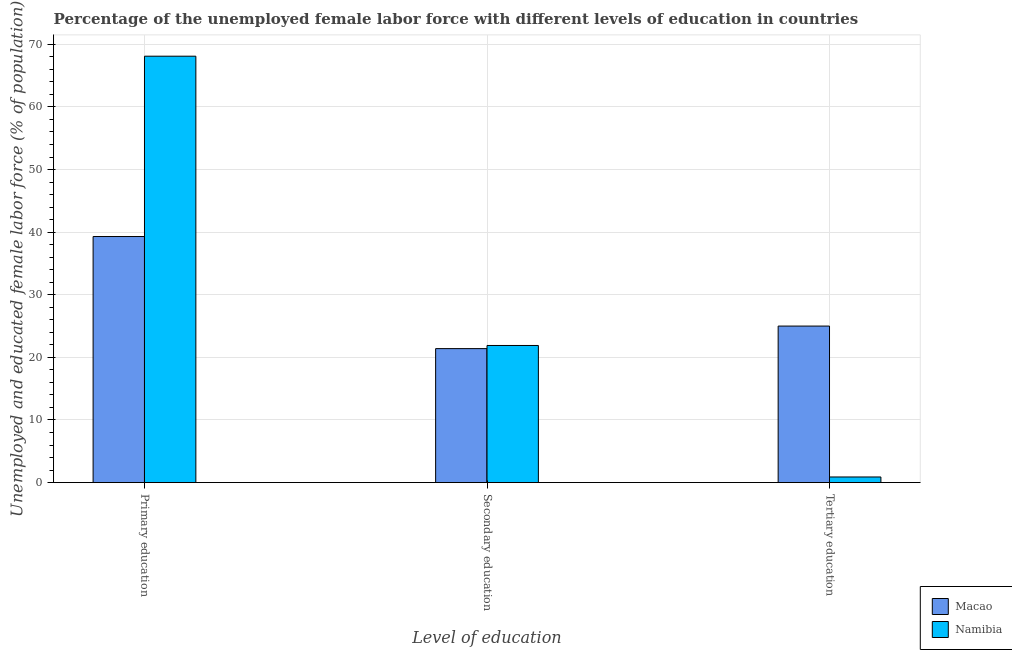How many bars are there on the 1st tick from the right?
Provide a succinct answer. 2. What is the label of the 3rd group of bars from the left?
Your response must be concise. Tertiary education. What is the percentage of female labor force who received tertiary education in Namibia?
Make the answer very short. 0.9. Across all countries, what is the maximum percentage of female labor force who received tertiary education?
Provide a short and direct response. 25. Across all countries, what is the minimum percentage of female labor force who received primary education?
Offer a very short reply. 39.3. In which country was the percentage of female labor force who received tertiary education maximum?
Your response must be concise. Macao. In which country was the percentage of female labor force who received tertiary education minimum?
Offer a very short reply. Namibia. What is the total percentage of female labor force who received tertiary education in the graph?
Offer a very short reply. 25.9. What is the difference between the percentage of female labor force who received secondary education in Macao and that in Namibia?
Ensure brevity in your answer.  -0.5. What is the difference between the percentage of female labor force who received primary education in Namibia and the percentage of female labor force who received tertiary education in Macao?
Give a very brief answer. 43.1. What is the average percentage of female labor force who received tertiary education per country?
Offer a very short reply. 12.95. What is the difference between the percentage of female labor force who received primary education and percentage of female labor force who received tertiary education in Namibia?
Your answer should be compact. 67.2. In how many countries, is the percentage of female labor force who received secondary education greater than 24 %?
Offer a very short reply. 0. What is the ratio of the percentage of female labor force who received primary education in Namibia to that in Macao?
Offer a terse response. 1.73. Is the difference between the percentage of female labor force who received tertiary education in Macao and Namibia greater than the difference between the percentage of female labor force who received primary education in Macao and Namibia?
Offer a terse response. Yes. What is the difference between the highest and the second highest percentage of female labor force who received secondary education?
Give a very brief answer. 0.5. What is the difference between the highest and the lowest percentage of female labor force who received tertiary education?
Your answer should be very brief. 24.1. What does the 2nd bar from the left in Secondary education represents?
Keep it short and to the point. Namibia. What does the 2nd bar from the right in Tertiary education represents?
Provide a succinct answer. Macao. Are all the bars in the graph horizontal?
Make the answer very short. No. How many countries are there in the graph?
Give a very brief answer. 2. Does the graph contain any zero values?
Provide a short and direct response. No. Where does the legend appear in the graph?
Offer a terse response. Bottom right. How many legend labels are there?
Give a very brief answer. 2. How are the legend labels stacked?
Offer a terse response. Vertical. What is the title of the graph?
Keep it short and to the point. Percentage of the unemployed female labor force with different levels of education in countries. What is the label or title of the X-axis?
Give a very brief answer. Level of education. What is the label or title of the Y-axis?
Offer a very short reply. Unemployed and educated female labor force (% of population). What is the Unemployed and educated female labor force (% of population) of Macao in Primary education?
Provide a short and direct response. 39.3. What is the Unemployed and educated female labor force (% of population) in Namibia in Primary education?
Provide a short and direct response. 68.1. What is the Unemployed and educated female labor force (% of population) in Macao in Secondary education?
Make the answer very short. 21.4. What is the Unemployed and educated female labor force (% of population) of Namibia in Secondary education?
Make the answer very short. 21.9. What is the Unemployed and educated female labor force (% of population) of Macao in Tertiary education?
Provide a succinct answer. 25. What is the Unemployed and educated female labor force (% of population) of Namibia in Tertiary education?
Your answer should be very brief. 0.9. Across all Level of education, what is the maximum Unemployed and educated female labor force (% of population) in Macao?
Make the answer very short. 39.3. Across all Level of education, what is the maximum Unemployed and educated female labor force (% of population) in Namibia?
Ensure brevity in your answer.  68.1. Across all Level of education, what is the minimum Unemployed and educated female labor force (% of population) of Macao?
Ensure brevity in your answer.  21.4. Across all Level of education, what is the minimum Unemployed and educated female labor force (% of population) in Namibia?
Make the answer very short. 0.9. What is the total Unemployed and educated female labor force (% of population) of Macao in the graph?
Your answer should be very brief. 85.7. What is the total Unemployed and educated female labor force (% of population) in Namibia in the graph?
Offer a terse response. 90.9. What is the difference between the Unemployed and educated female labor force (% of population) in Namibia in Primary education and that in Secondary education?
Give a very brief answer. 46.2. What is the difference between the Unemployed and educated female labor force (% of population) of Macao in Primary education and that in Tertiary education?
Make the answer very short. 14.3. What is the difference between the Unemployed and educated female labor force (% of population) of Namibia in Primary education and that in Tertiary education?
Ensure brevity in your answer.  67.2. What is the difference between the Unemployed and educated female labor force (% of population) in Macao in Secondary education and that in Tertiary education?
Your answer should be very brief. -3.6. What is the difference between the Unemployed and educated female labor force (% of population) in Macao in Primary education and the Unemployed and educated female labor force (% of population) in Namibia in Tertiary education?
Your answer should be compact. 38.4. What is the difference between the Unemployed and educated female labor force (% of population) of Macao in Secondary education and the Unemployed and educated female labor force (% of population) of Namibia in Tertiary education?
Your answer should be very brief. 20.5. What is the average Unemployed and educated female labor force (% of population) of Macao per Level of education?
Provide a short and direct response. 28.57. What is the average Unemployed and educated female labor force (% of population) in Namibia per Level of education?
Make the answer very short. 30.3. What is the difference between the Unemployed and educated female labor force (% of population) of Macao and Unemployed and educated female labor force (% of population) of Namibia in Primary education?
Your answer should be very brief. -28.8. What is the difference between the Unemployed and educated female labor force (% of population) of Macao and Unemployed and educated female labor force (% of population) of Namibia in Secondary education?
Offer a terse response. -0.5. What is the difference between the Unemployed and educated female labor force (% of population) of Macao and Unemployed and educated female labor force (% of population) of Namibia in Tertiary education?
Your response must be concise. 24.1. What is the ratio of the Unemployed and educated female labor force (% of population) in Macao in Primary education to that in Secondary education?
Your answer should be very brief. 1.84. What is the ratio of the Unemployed and educated female labor force (% of population) in Namibia in Primary education to that in Secondary education?
Your response must be concise. 3.11. What is the ratio of the Unemployed and educated female labor force (% of population) of Macao in Primary education to that in Tertiary education?
Ensure brevity in your answer.  1.57. What is the ratio of the Unemployed and educated female labor force (% of population) in Namibia in Primary education to that in Tertiary education?
Make the answer very short. 75.67. What is the ratio of the Unemployed and educated female labor force (% of population) of Macao in Secondary education to that in Tertiary education?
Provide a succinct answer. 0.86. What is the ratio of the Unemployed and educated female labor force (% of population) in Namibia in Secondary education to that in Tertiary education?
Your answer should be compact. 24.33. What is the difference between the highest and the second highest Unemployed and educated female labor force (% of population) in Macao?
Your answer should be very brief. 14.3. What is the difference between the highest and the second highest Unemployed and educated female labor force (% of population) in Namibia?
Offer a very short reply. 46.2. What is the difference between the highest and the lowest Unemployed and educated female labor force (% of population) of Macao?
Give a very brief answer. 17.9. What is the difference between the highest and the lowest Unemployed and educated female labor force (% of population) in Namibia?
Keep it short and to the point. 67.2. 